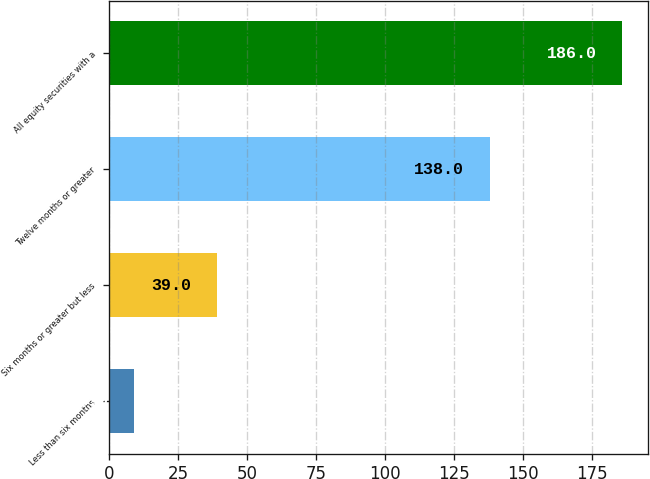Convert chart. <chart><loc_0><loc_0><loc_500><loc_500><bar_chart><fcel>Less than six months<fcel>Six months or greater but less<fcel>Twelve months or greater<fcel>All equity securities with a<nl><fcel>9<fcel>39<fcel>138<fcel>186<nl></chart> 